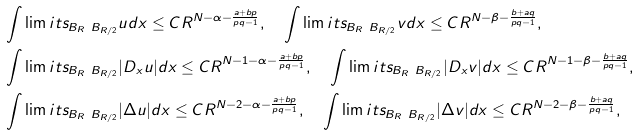Convert formula to latex. <formula><loc_0><loc_0><loc_500><loc_500>& \int \lim i t s _ { B _ { R } \ B _ { R / 2 } } u d x \leq C R ^ { N - \alpha - \frac { a + b p } { p q - 1 } } , \quad \int \lim i t s _ { B _ { R } \ B _ { R / 2 } } v d x \leq C R ^ { N - \beta - \frac { b + a q } { p q - 1 } } , \\ & \int \lim i t s _ { B _ { R } \ B _ { R / 2 } } | D _ { x } u | d x \leq C R ^ { N - 1 - \alpha - \frac { a + b p } { p q - 1 } } , \quad \int \lim i t s _ { B _ { R } \ B _ { R / 2 } } | D _ { x } v | d x \leq C R ^ { N - 1 - \beta - \frac { b + a q } { p q - 1 } } , \\ & \int \lim i t s _ { B _ { R } \ B _ { R / 2 } } | \Delta u | d x \leq C R ^ { N - 2 - \alpha - \frac { a + b p } { p q - 1 } } , \quad \int \lim i t s _ { B _ { R } \ B _ { R / 2 } } | \Delta v | d x \leq C R ^ { N - 2 - \beta - \frac { b + a q } { p q - 1 } } ,</formula> 